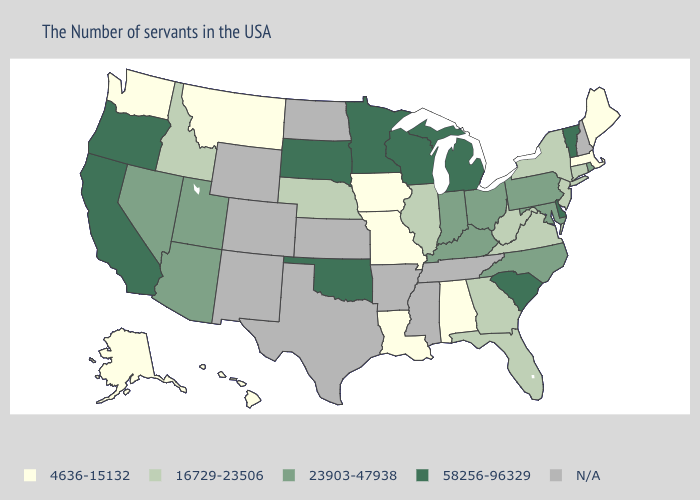What is the lowest value in the USA?
Short answer required. 4636-15132. Name the states that have a value in the range 23903-47938?
Give a very brief answer. Rhode Island, Maryland, Pennsylvania, North Carolina, Ohio, Kentucky, Indiana, Utah, Arizona, Nevada. Does Alaska have the highest value in the USA?
Be succinct. No. Which states have the lowest value in the West?
Be succinct. Montana, Washington, Alaska, Hawaii. Which states have the lowest value in the USA?
Give a very brief answer. Maine, Massachusetts, Alabama, Louisiana, Missouri, Iowa, Montana, Washington, Alaska, Hawaii. Does Vermont have the highest value in the Northeast?
Concise answer only. Yes. What is the lowest value in the USA?
Quick response, please. 4636-15132. Among the states that border Maryland , does Pennsylvania have the highest value?
Quick response, please. No. What is the value of Missouri?
Keep it brief. 4636-15132. What is the highest value in the West ?
Answer briefly. 58256-96329. Name the states that have a value in the range 4636-15132?
Write a very short answer. Maine, Massachusetts, Alabama, Louisiana, Missouri, Iowa, Montana, Washington, Alaska, Hawaii. What is the value of Connecticut?
Answer briefly. 16729-23506. Does the first symbol in the legend represent the smallest category?
Keep it brief. Yes. Name the states that have a value in the range 23903-47938?
Concise answer only. Rhode Island, Maryland, Pennsylvania, North Carolina, Ohio, Kentucky, Indiana, Utah, Arizona, Nevada. Which states have the highest value in the USA?
Keep it brief. Vermont, Delaware, South Carolina, Michigan, Wisconsin, Minnesota, Oklahoma, South Dakota, California, Oregon. 